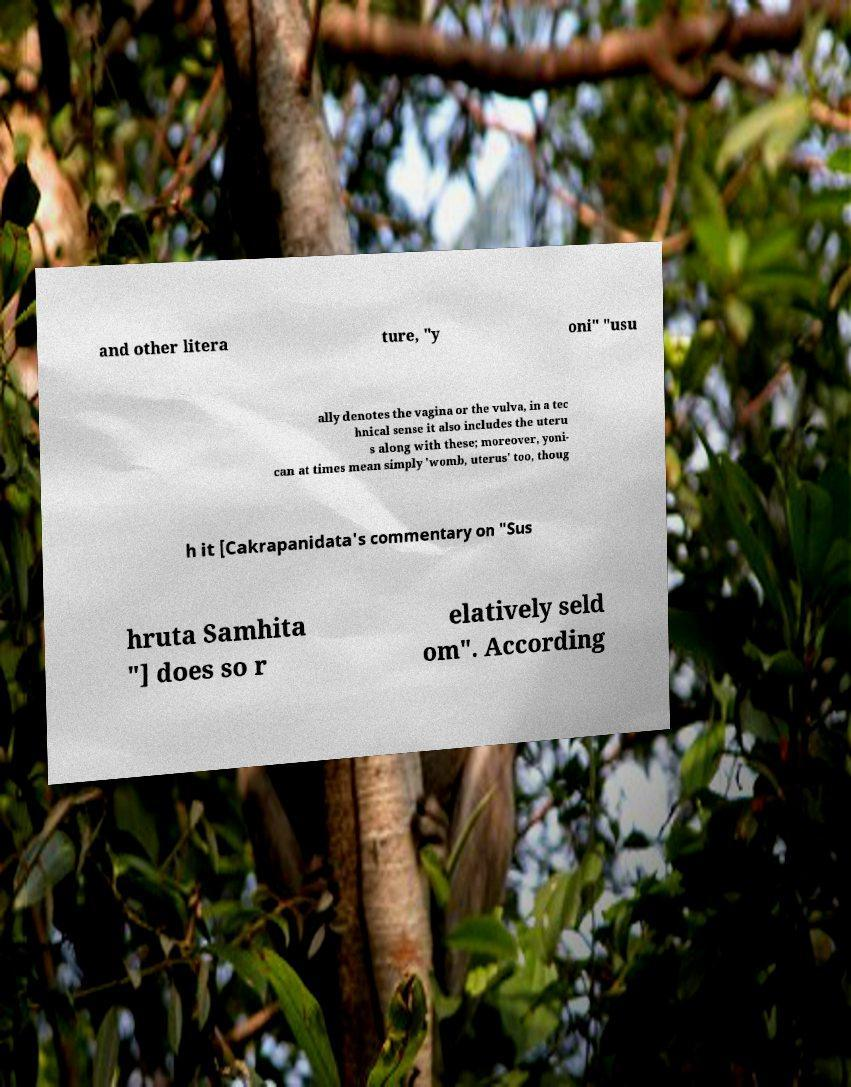Can you read and provide the text displayed in the image?This photo seems to have some interesting text. Can you extract and type it out for me? and other litera ture, "y oni" "usu ally denotes the vagina or the vulva, in a tec hnical sense it also includes the uteru s along with these; moreover, yoni- can at times mean simply 'womb, uterus' too, thoug h it [Cakrapanidata's commentary on "Sus hruta Samhita "] does so r elatively seld om". According 